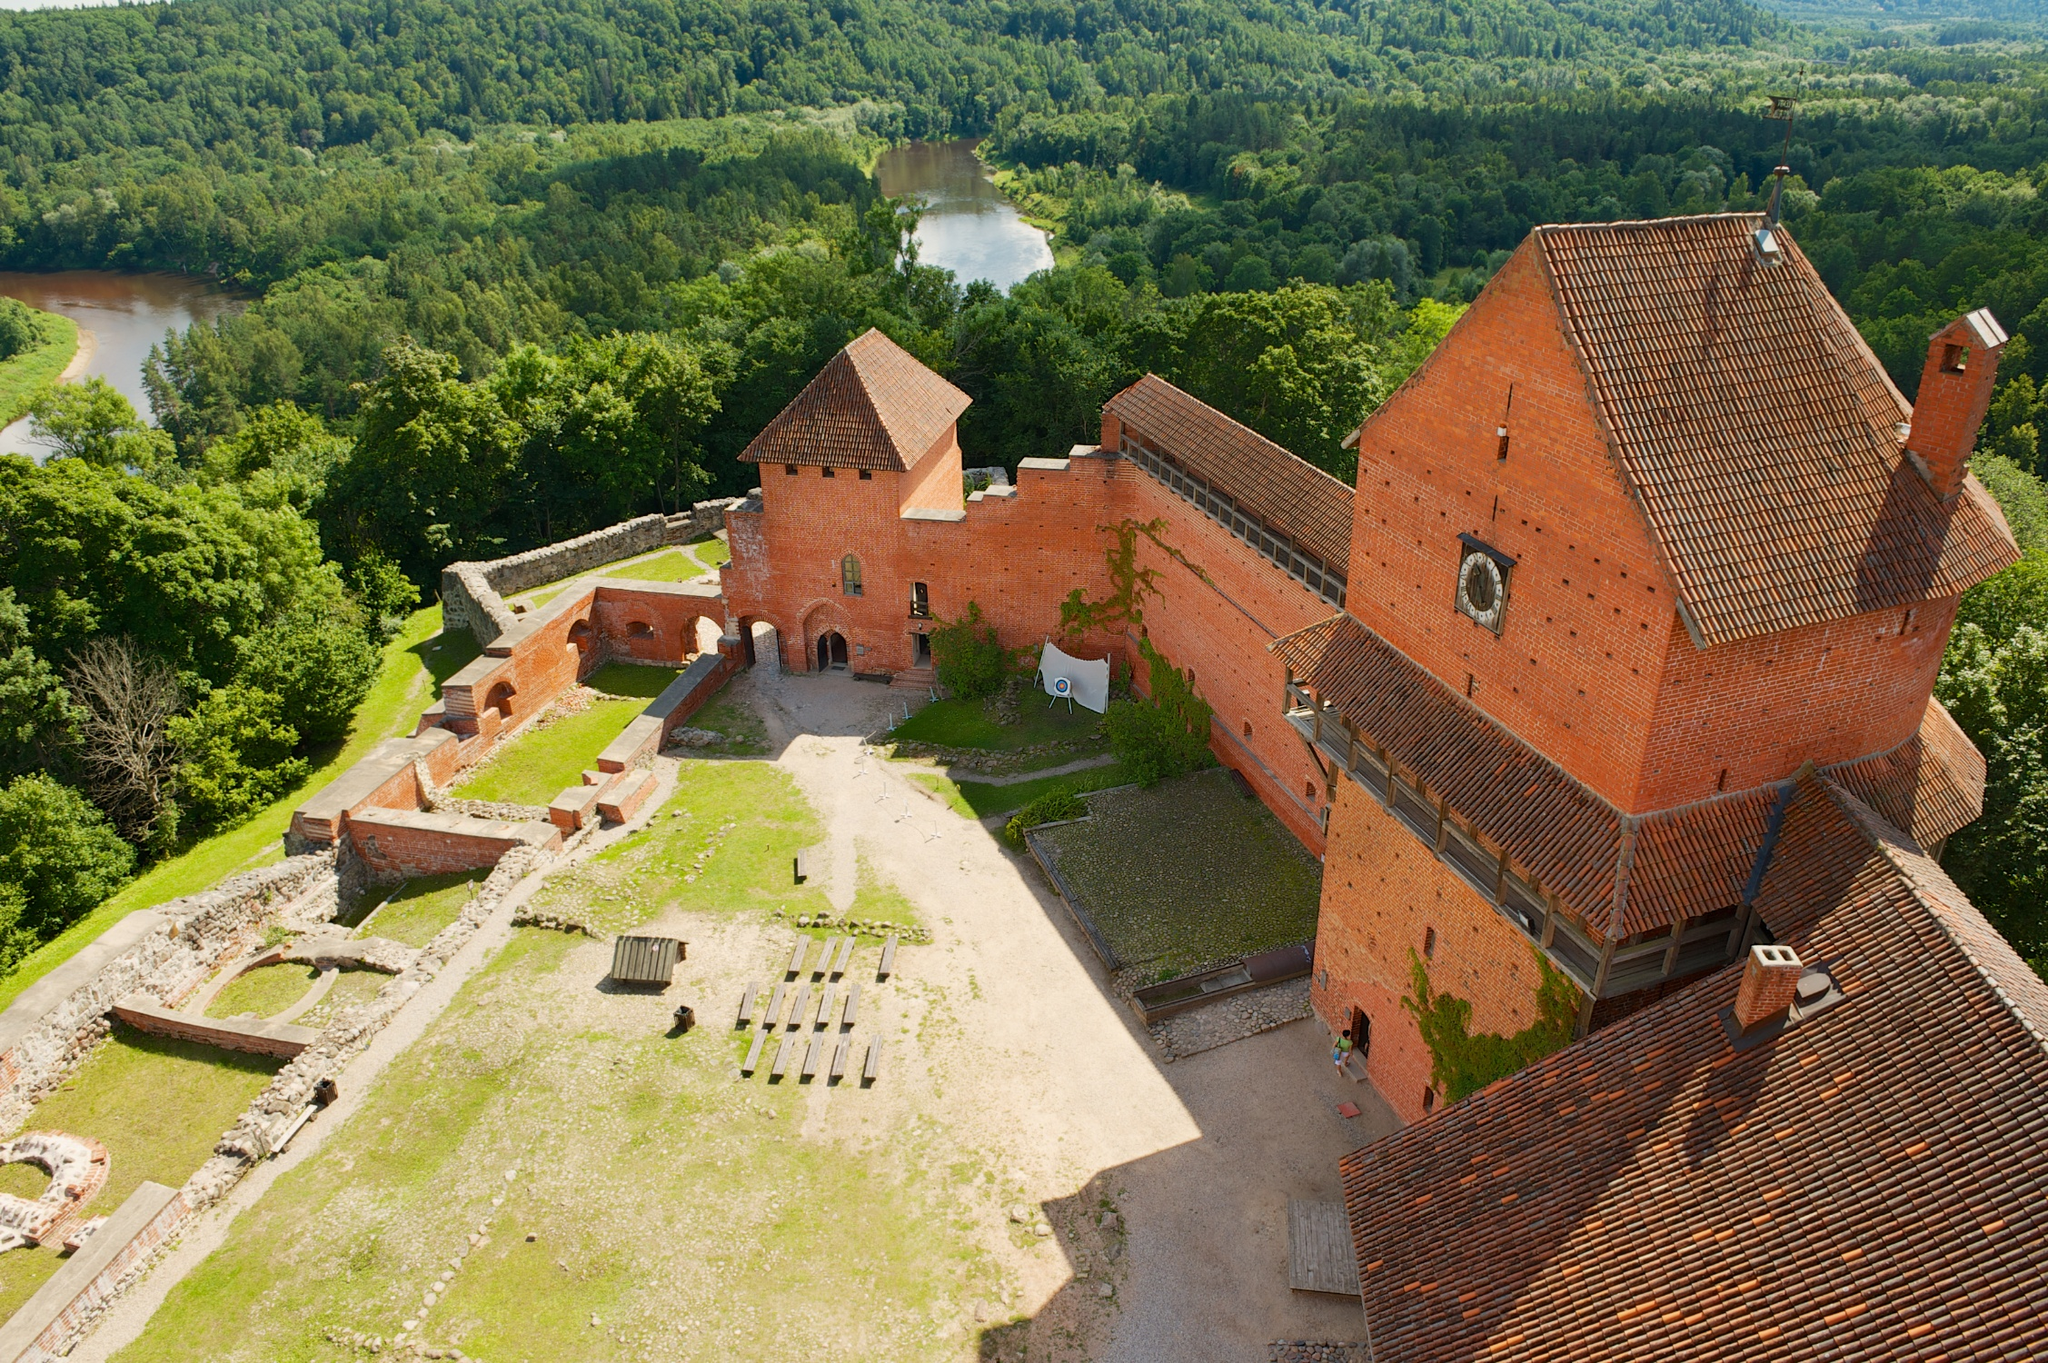If an archaeologist were to excavate part of this castle, what might they find? If an archaeologist were to excavate parts of this castle, they might uncover a treasure trove of artifacts that offer a glimpse into medieval life. They could find remnants of old pottery, ancient coins, and intricately designed weapons. Beneath the castle grounds, hidden chambers and storage rooms might reveal preserved manuscripts, scrolls, and banners showcasing heraldic symbols. Architectural elements like ornate stone carvings, sections of collapsed walls, and remnants of wooden structures would help piece together the castle's historical evolution. Additionally, personal items such as jewelry, clothing fragments, and tools would provide insights into the daily lives of the castle's inhabitants and their social hierarchy. 